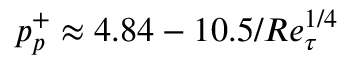<formula> <loc_0><loc_0><loc_500><loc_500>p _ { p } ^ { + } \approx 4 . 8 4 - 1 0 . 5 / R e _ { \tau } ^ { 1 / 4 }</formula> 